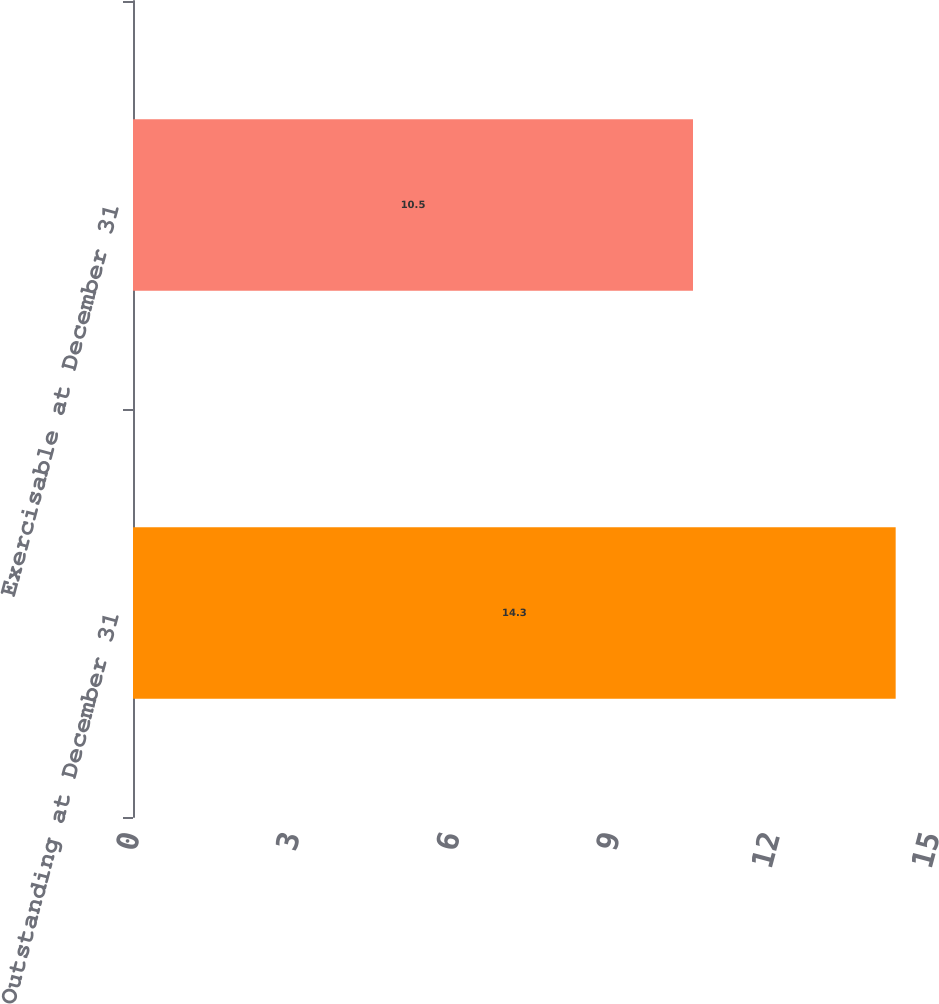Convert chart to OTSL. <chart><loc_0><loc_0><loc_500><loc_500><bar_chart><fcel>Outstanding at December 31<fcel>Exercisable at December 31<nl><fcel>14.3<fcel>10.5<nl></chart> 